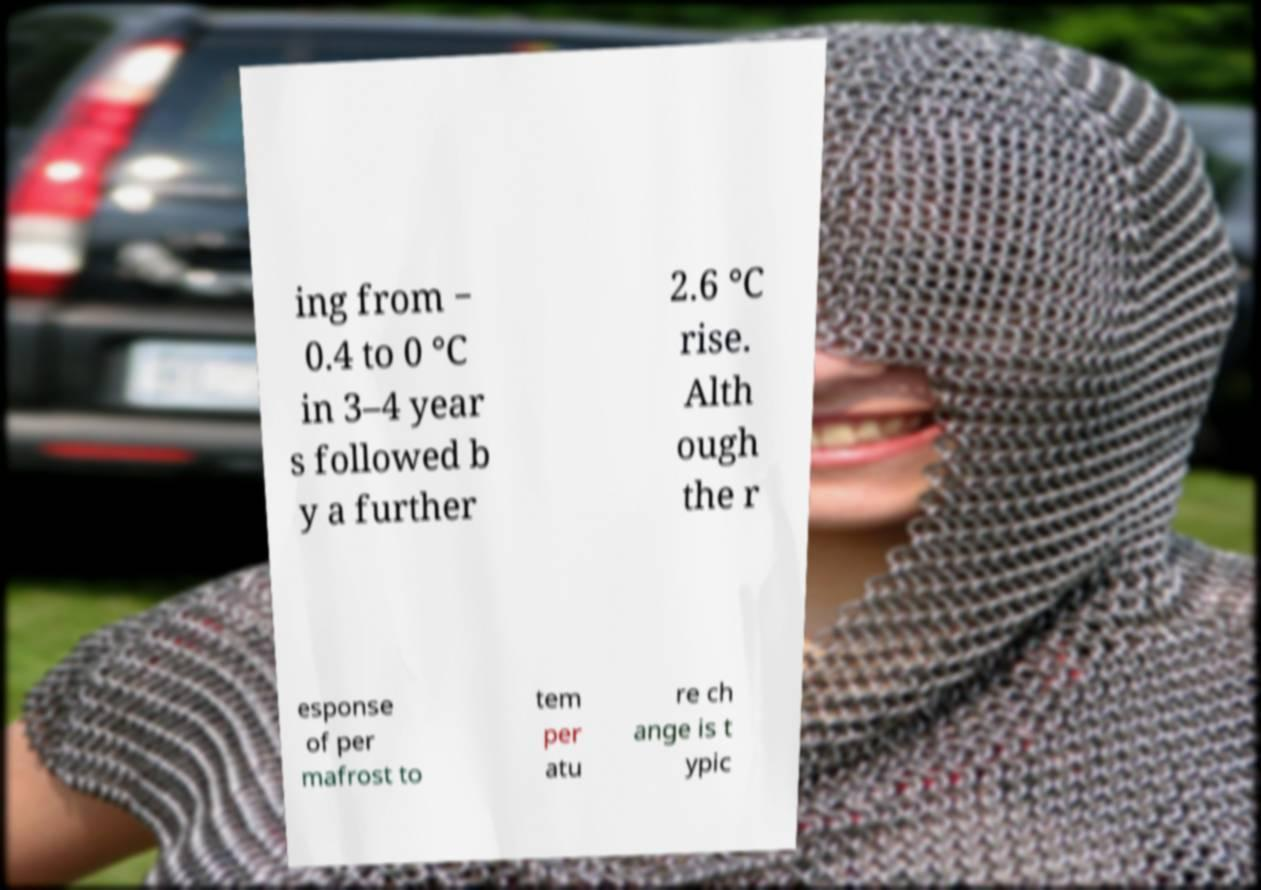Please identify and transcribe the text found in this image. ing from − 0.4 to 0 °C in 3–4 year s followed b y a further 2.6 °C rise. Alth ough the r esponse of per mafrost to tem per atu re ch ange is t ypic 